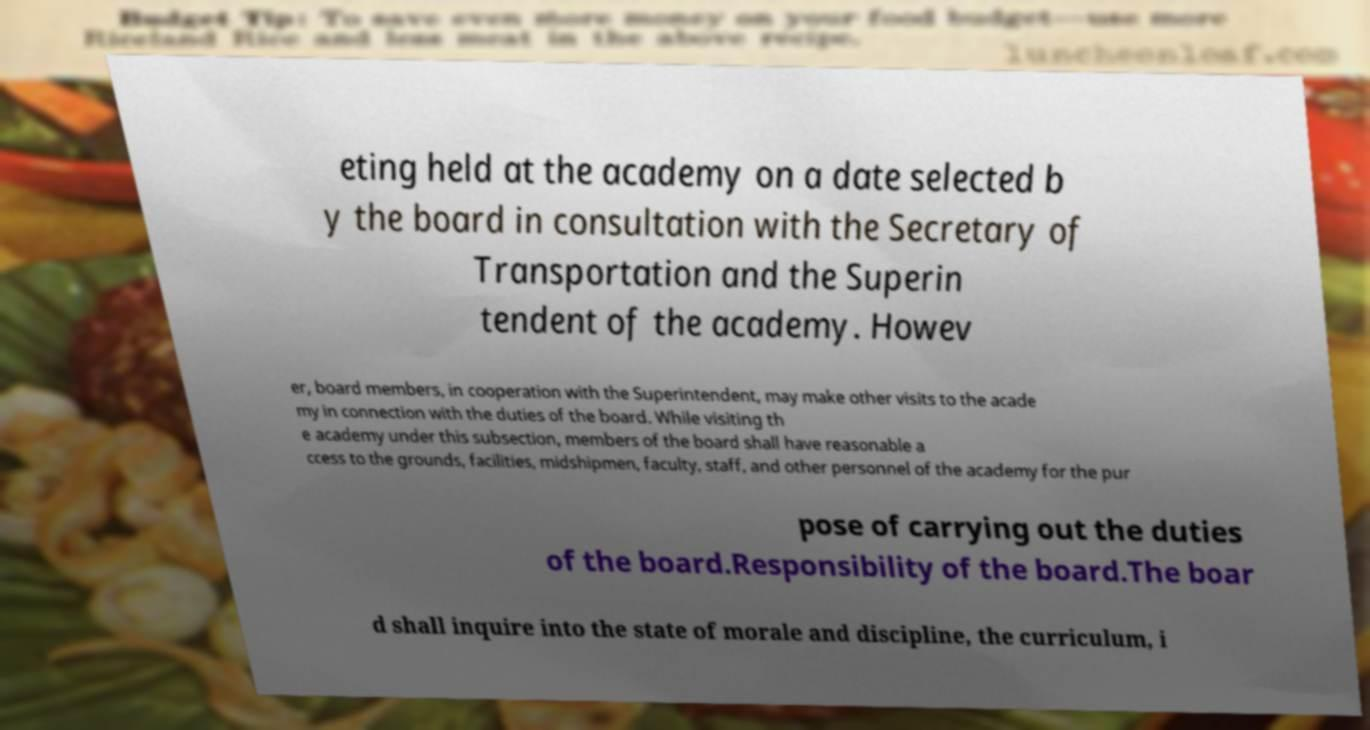Could you extract and type out the text from this image? eting held at the academy on a date selected b y the board in consultation with the Secretary of Transportation and the Superin tendent of the academy. Howev er, board members, in cooperation with the Superintendent, may make other visits to the acade my in connection with the duties of the board. While visiting th e academy under this subsection, members of the board shall have reasonable a ccess to the grounds, facilities, midshipmen, faculty, staff, and other personnel of the academy for the pur pose of carrying out the duties of the board.Responsibility of the board.The boar d shall inquire into the state of morale and discipline, the curriculum, i 